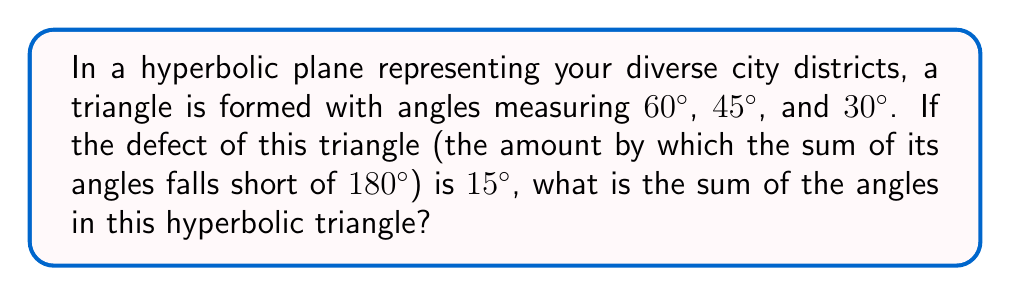Can you answer this question? Let's approach this step-by-step:

1) In Euclidean geometry, the sum of angles in a triangle is always $180°$. However, in hyperbolic geometry, this sum is always less than $180°$.

2) The defect of a hyperbolic triangle is defined as:

   $$ \text{Defect} = 180° - (\text{Sum of angles in the hyperbolic triangle}) $$

3) We are given that the defect is $15°$. Let's call the sum of angles in our hyperbolic triangle $S$. We can write:

   $$ 15° = 180° - S $$

4) To solve for $S$, we subtract both sides from $180°$:

   $$ S = 180° - 15° = 165° $$

5) We can verify this by adding the given angles:

   $$ 60° + 45° + 30° = 135° $$

   Indeed, this sum is less than $180°$ by $15°$, confirming our calculation.

6) Therefore, the sum of angles in this hyperbolic triangle is $165°$.
Answer: $165°$ 